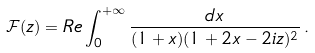<formula> <loc_0><loc_0><loc_500><loc_500>\mathcal { F } ( z ) = R e \int ^ { + \infty } _ { 0 } \frac { d x } { ( 1 + x ) ( 1 + 2 x - 2 i z ) ^ { 2 } } \, .</formula> 